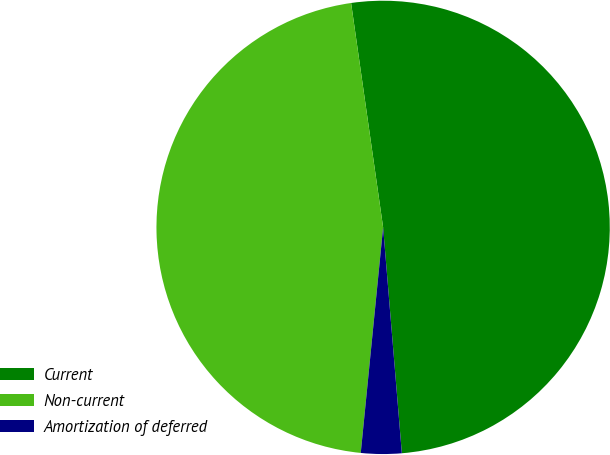Convert chart to OTSL. <chart><loc_0><loc_0><loc_500><loc_500><pie_chart><fcel>Current<fcel>Non-current<fcel>Amortization of deferred<nl><fcel>50.94%<fcel>46.17%<fcel>2.89%<nl></chart> 